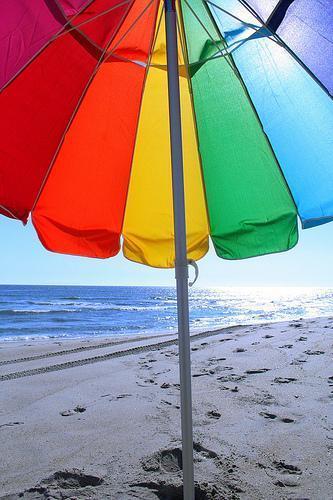How many umbrellas are there?
Give a very brief answer. 1. 